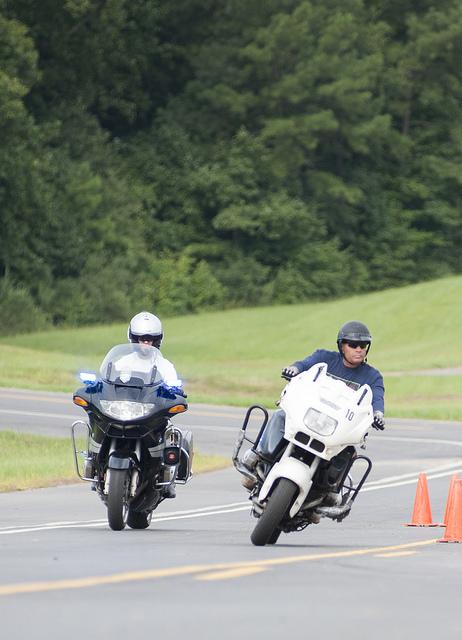Are these people traveling on a highway?
Be succinct. No. Are the riders wearing helmets?
Concise answer only. Yes. Is the bike running?
Be succinct. Yes. What color are the dashed lines on the ground?
Write a very short answer. Yellow. 